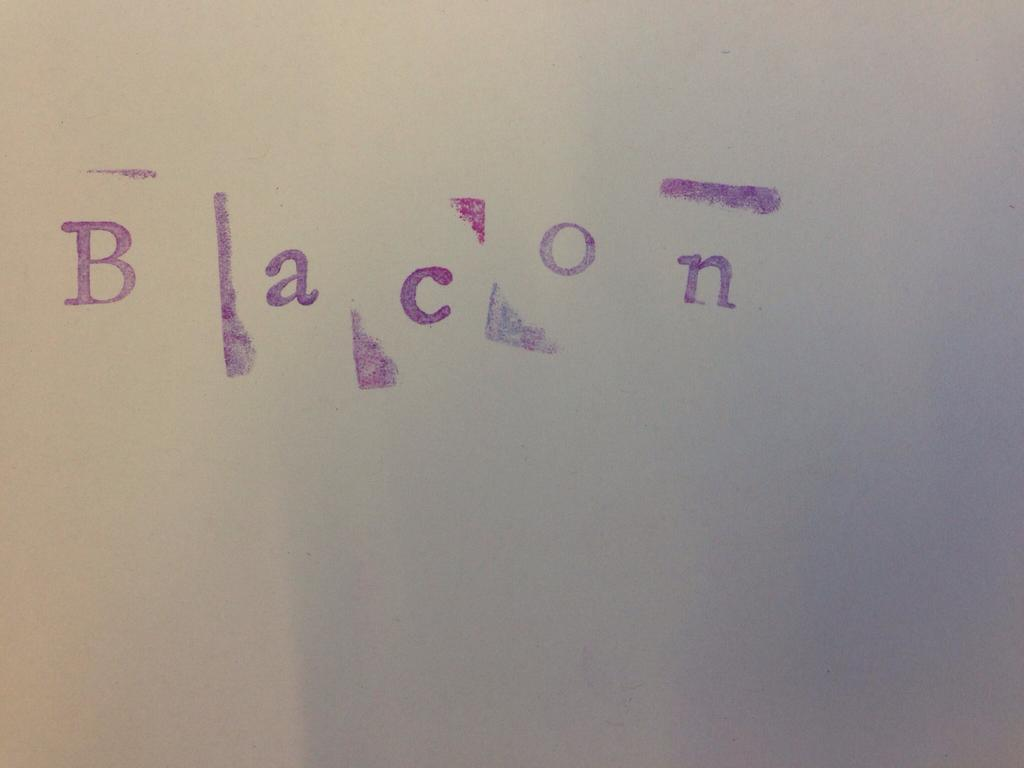<image>
Offer a succinct explanation of the picture presented. The word "bacon" is printed in purple stamp ink on white paper. 